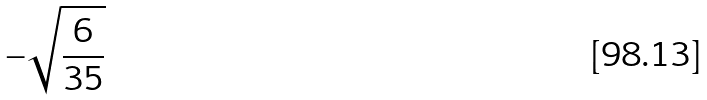<formula> <loc_0><loc_0><loc_500><loc_500>- \sqrt { \frac { 6 } { 3 5 } }</formula> 